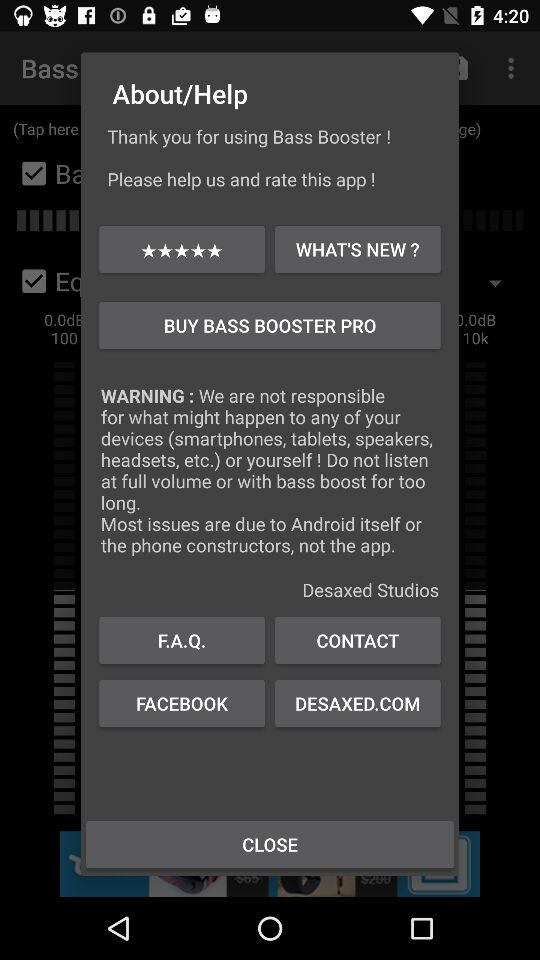How many ratings are given? The given rating is 5 stars. 